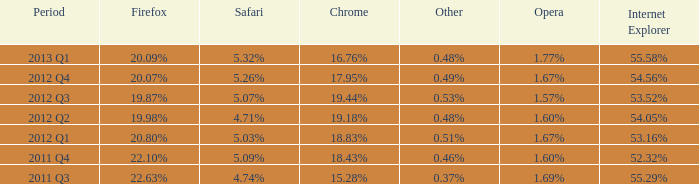What opera has 19.87% as the firefox? 1.57%. Parse the table in full. {'header': ['Period', 'Firefox', 'Safari', 'Chrome', 'Other', 'Opera', 'Internet Explorer'], 'rows': [['2013 Q1', '20.09%', '5.32%', '16.76%', '0.48%', '1.77%', '55.58%'], ['2012 Q4', '20.07%', '5.26%', '17.95%', '0.49%', '1.67%', '54.56%'], ['2012 Q3', '19.87%', '5.07%', '19.44%', '0.53%', '1.57%', '53.52%'], ['2012 Q2', '19.98%', '4.71%', '19.18%', '0.48%', '1.60%', '54.05%'], ['2012 Q1', '20.80%', '5.03%', '18.83%', '0.51%', '1.67%', '53.16%'], ['2011 Q4', '22.10%', '5.09%', '18.43%', '0.46%', '1.60%', '52.32%'], ['2011 Q3', '22.63%', '4.74%', '15.28%', '0.37%', '1.69%', '55.29%']]} 